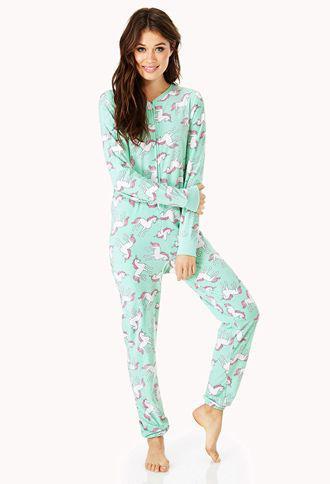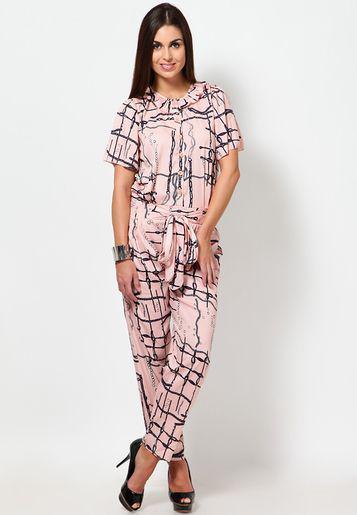The first image is the image on the left, the second image is the image on the right. Given the left and right images, does the statement "A pajama shirt in one image has solid contrasting trim on the shirt's bottom hem, pocket, and sleeve cuffs." hold true? Answer yes or no. No. The first image is the image on the left, the second image is the image on the right. Given the left and right images, does the statement "Right image shows one model in pajamas with solid trim at the hems." hold true? Answer yes or no. No. 